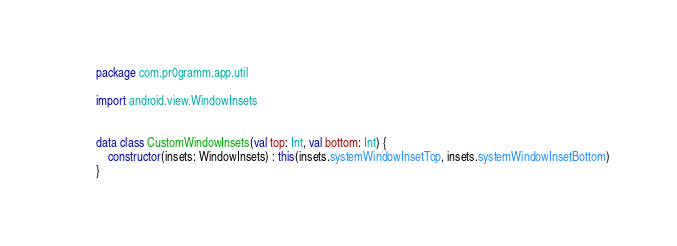Convert code to text. <code><loc_0><loc_0><loc_500><loc_500><_Kotlin_>package com.pr0gramm.app.util

import android.view.WindowInsets


data class CustomWindowInsets(val top: Int, val bottom: Int) {
    constructor(insets: WindowInsets) : this(insets.systemWindowInsetTop, insets.systemWindowInsetBottom)
}
</code> 